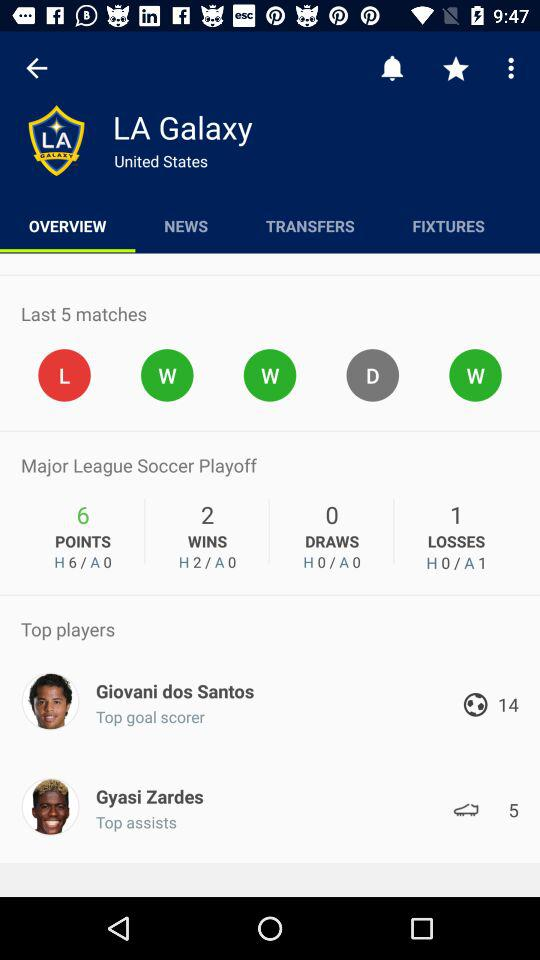Can you tell me about LA Galaxy's recent form? As shown in the image, LA Galaxy's recent form includes the results of their last five matches, which are depicted as L (Loss), W (Win), W (Win), D (Draw), and W (Win). This suggests a relatively positive performance, with only one loss in their last five games. 